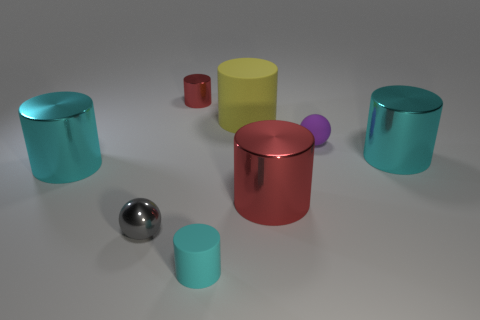How do the shadows and lighting in the image inform us about the environment? Based on the shadows and lighting, we can infer multiple light sources above the scene, as indicated by the multiple shadows cast by each object. The softness of the shadows suggests diffused lighting, possibly in an indoor setting with artificial lights. There's also a mild reflection on the ground, revealing it is likely a smooth and somewhat reflective surface. 